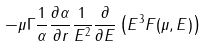Convert formula to latex. <formula><loc_0><loc_0><loc_500><loc_500>- \mu \Gamma \frac { 1 } { \alpha } \frac { \partial \alpha } { \partial r } \frac { 1 } { E ^ { 2 } } \frac { \partial } { \partial E } \left ( E ^ { 3 } F ( \mu , E ) \right )</formula> 